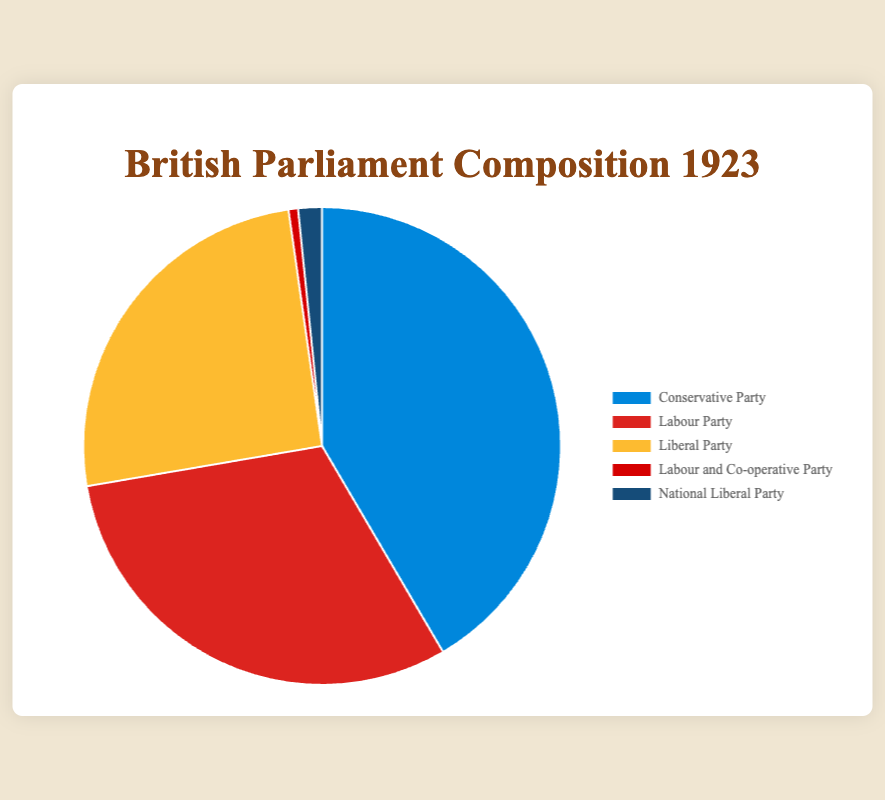what is the total number of seats represented in the pie chart? Sum the seats for each party: 258 (Conservative) + 191 (Labour) + 158 (Liberal) + 4 (Labour and Co-operative) + 10 (National Liberal) = 621
Answer: 621 Which party has the highest number of seats? The party with the highest numerical value in the data is the Conservative Party with 258 seats
Answer: Conservative Party How many more seats does the Conservative Party have than the Labour Party? Subtract the Labour Party's seats from the Conservative Party's seats: 258 - 191 = 67
Answer: 67 What percentage of seats does the Labour and Co-operative Party hold? Divide the Labour and Co-operative seats by the total, then multiply by 100 to get the percentage: (4/621) * 100 ≈ 0.64%
Answer: ~0.64% Which parties together hold fewer seats than the Liberal Party? Sum the seats of Labour and Co-operative (4) and National Liberal (10): 4 + 10 = 14, which is less than the Liberal Party's 158 seats
Answer: Labour and Co-operative, National Liberal What is the sum of the seats held by the three largest parties? Add the seats of the three largest parties (Conservative, Labour, and Liberal): 258 + 191 + 158 = 607
Answer: 607 Is the number of seats held by the National Liberal Party more than twice the seats held by the Labour and Co-operative Party? Multiply the Labour and Co-operative seats by 2: 2 * 4 = 8. Compare it to the National Liberal seats: 10 > 8
Answer: Yes What color represents the Liberal Party in the pie chart? Identify the color assigned to the Liberal Party from the color scheme used in the chart: Yellow
Answer: Yellow 